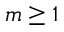<formula> <loc_0><loc_0><loc_500><loc_500>m \geq 1</formula> 